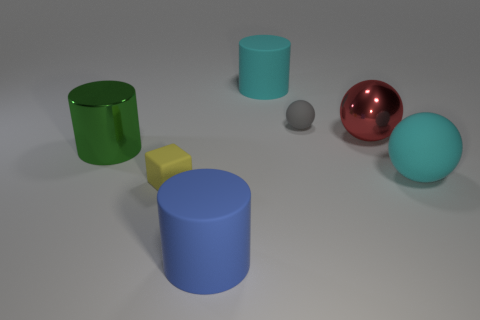Does the cyan matte sphere have the same size as the green metal object? While both the cyan matte sphere and the green metal cylinder appear similar in size, upon closer observation, the cyan sphere is marginally larger. This is because the sphere's dimension is uniform in all directions, whereas the cylinder's height and diameter can differ, making direct comparisons more nuanced. 